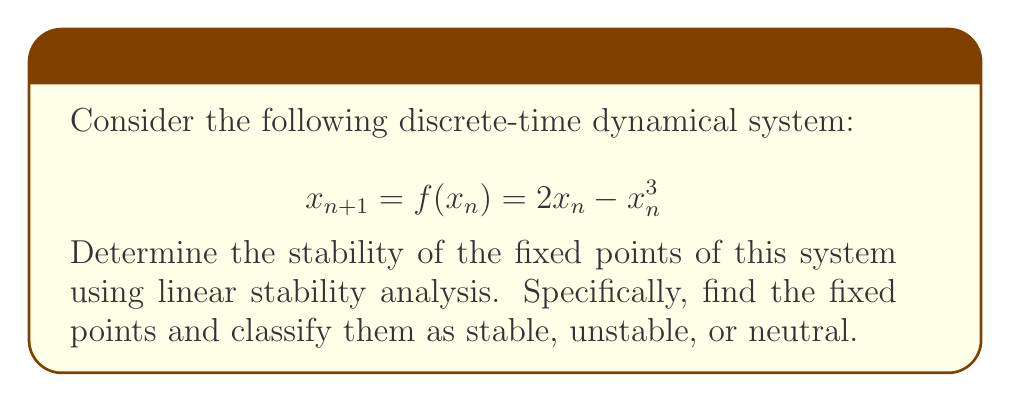Solve this math problem. 1. Find the fixed points:
   Set $x_{n+1} = x_n = x^*$
   $$x^* = 2x^* - (x^*)^3$$
   $$(x^*)^3 - 2x^* + x^* = 0$$
   $$(x^*)^3 - x^* = 0$$
   $$x^*((x^*)^2 - 1) = 0$$
   So, $x^* = 0, 1, -1$

2. Perform linear stability analysis:
   Calculate $f'(x) = 2 - 3x^2$

3. Evaluate $f'(x)$ at each fixed point:
   At $x^* = 0$: $f'(0) = 2$
   At $x^* = 1$: $f'(1) = 2 - 3 = -1$
   At $x^* = -1$: $f'(-1) = 2 - 3 = -1$

4. Classify stability:
   - If $|f'(x^*)| < 1$, the fixed point is stable
   - If $|f'(x^*)| > 1$, the fixed point is unstable
   - If $|f'(x^*)| = 1$, the fixed point is neutral (further analysis needed)

   For $x^* = 0$: $|f'(0)| = |2| > 1$, so it's unstable
   For $x^* = 1$: $|f'(1)| = |-1| = 1$, so it's neutral
   For $x^* = -1$: $|f'(-1)| = |-1| = 1$, so it's neutral

5. For neutral fixed points, we need to consider higher-order terms:
   Near $x^* = 1$: $f(x) \approx 1 - (x-1) + O((x-1)^2)$
   This suggests that $x^* = 1$ is actually stable from one side and unstable from the other.
   
   Near $x^* = -1$: $f(x) \approx -1 - (x+1) + O((x+1)^2)$
   This suggests that $x^* = -1$ is also stable from one side and unstable from the other.
Answer: $x^* = 0$ (unstable), $x^* = \pm 1$ (semi-stable) 